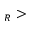<formula> <loc_0><loc_0><loc_500><loc_500>_ { R } ></formula> 